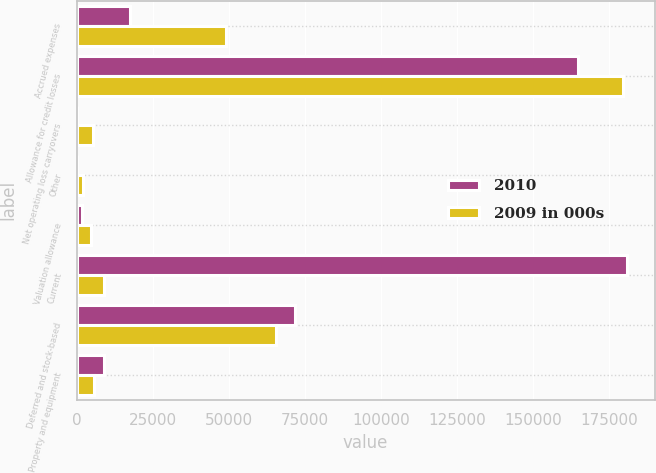<chart> <loc_0><loc_0><loc_500><loc_500><stacked_bar_chart><ecel><fcel>Accrued expenses<fcel>Allowance for credit losses<fcel>Net operating loss carryovers<fcel>Other<fcel>Valuation allowance<fcel>Current<fcel>Deferred and stock-based<fcel>Property and equipment<nl><fcel>2010<fcel>17554<fcel>164783<fcel>200<fcel>237<fcel>1745<fcel>181029<fcel>71970<fcel>9071<nl><fcel>2009 in 000s<fcel>49239<fcel>179508<fcel>5495<fcel>2119<fcel>4773<fcel>9071<fcel>65493<fcel>5743<nl></chart> 